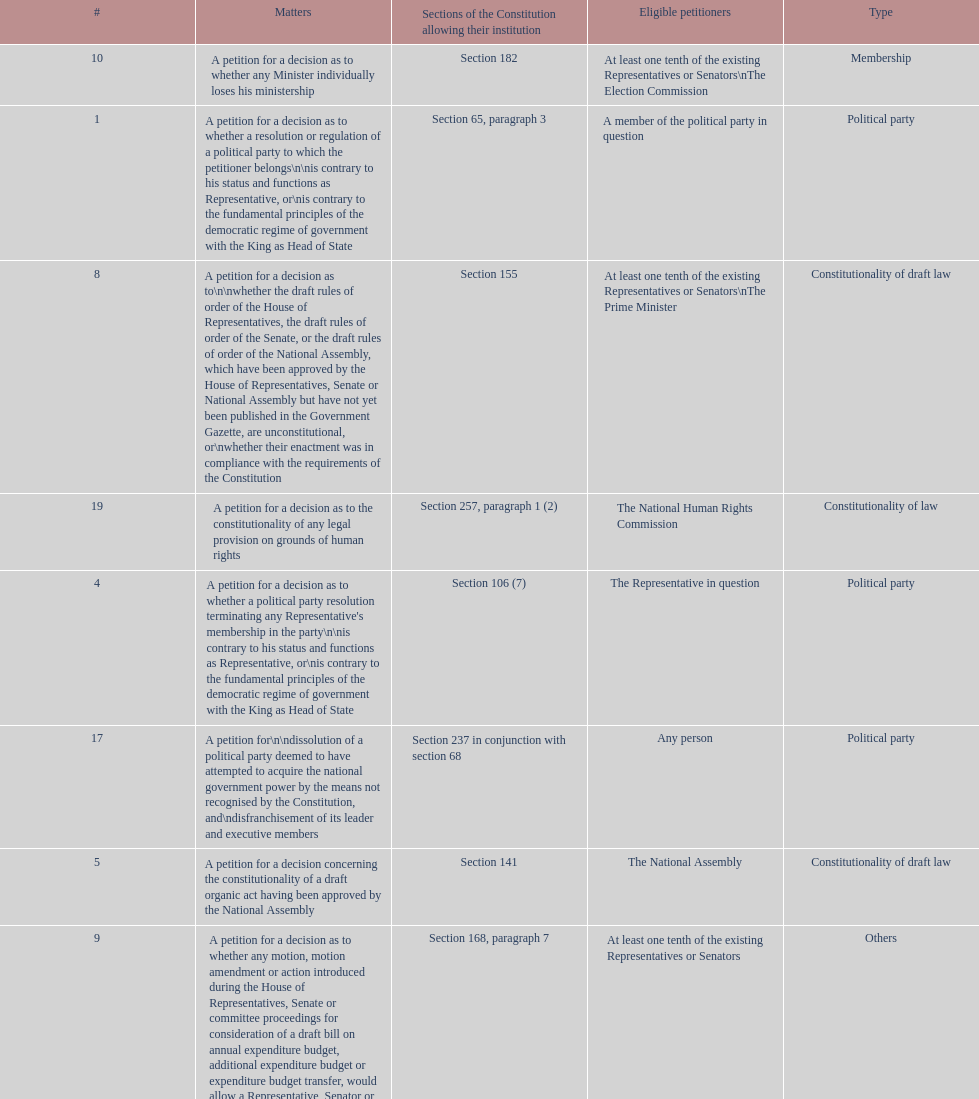Any person can petition matters 2 and 17. true or false? True. Can you parse all the data within this table? {'header': ['#', 'Matters', 'Sections of the Constitution allowing their institution', 'Eligible petitioners', 'Type'], 'rows': [['10', 'A petition for a decision as to whether any Minister individually loses his ministership', 'Section 182', 'At least one tenth of the existing Representatives or Senators\\nThe Election Commission', 'Membership'], ['1', 'A petition for a decision as to whether a resolution or regulation of a political party to which the petitioner belongs\\n\\nis contrary to his status and functions as Representative, or\\nis contrary to the fundamental principles of the democratic regime of government with the King as Head of State', 'Section 65, paragraph 3', 'A member of the political party in question', 'Political party'], ['8', 'A petition for a decision as to\\n\\nwhether the draft rules of order of the House of Representatives, the draft rules of order of the Senate, or the draft rules of order of the National Assembly, which have been approved by the House of Representatives, Senate or National Assembly but have not yet been published in the Government Gazette, are unconstitutional, or\\nwhether their enactment was in compliance with the requirements of the Constitution', 'Section 155', 'At least one tenth of the existing Representatives or Senators\\nThe Prime Minister', 'Constitutionality of draft law'], ['19', 'A petition for a decision as to the constitutionality of any legal provision on grounds of human rights', 'Section 257, paragraph 1 (2)', 'The National Human Rights Commission', 'Constitutionality of law'], ['4', "A petition for a decision as to whether a political party resolution terminating any Representative's membership in the party\\n\\nis contrary to his status and functions as Representative, or\\nis contrary to the fundamental principles of the democratic regime of government with the King as Head of State", 'Section 106 (7)', 'The Representative in question', 'Political party'], ['17', 'A petition for\\n\\ndissolution of a political party deemed to have attempted to acquire the national government power by the means not recognised by the Constitution, and\\ndisfranchisement of its leader and executive members', 'Section 237 in conjunction with section 68', 'Any person', 'Political party'], ['5', 'A petition for a decision concerning the constitutionality of a draft organic act having been approved by the National Assembly', 'Section 141', 'The National Assembly', 'Constitutionality of draft law'], ['9', 'A petition for a decision as to whether any motion, motion amendment or action introduced during the House of Representatives, Senate or committee proceedings for consideration of a draft bill on annual expenditure budget, additional expenditure budget or expenditure budget transfer, would allow a Representative, Senator or committee member to directly or indirectly be involved in the disbursement of such budget', 'Section 168, paragraph 7', 'At least one tenth of the existing Representatives or Senators', 'Others'], ['14', 'A petition for a decision as to the constitutionality of a legal provision', 'Section 212', 'Any person whose constitutionally recognised right or freedom has been violated', 'Constitutionality of law'], ['6', 'A petition for a decision as to whether a draft organic act or act introduced by the Council of Ministers or Representatives bears the principle identical or similar to that which needs to be suppressed', 'Sections 140 and 149', 'The President of the House of Representatives or Senate', 'Constitutionality of draft law'], ['3', 'A petition for a decision as to whether any Representative or Senator loses his membership by operation of the Constitution', 'Section 91', 'At least one tenth of the existing Representatives or Senators', 'Membership'], ['15', 'A petition for a decision as to a conflict of authority between the National Assembly, the Council of Ministers, or two or more constitutional organs other than the courts of justice, administrative courts or military courts', 'Section 214', 'The President of the National Assembly\\nThe Prime Minister\\nThe organs in question', 'Authority'], ['18', 'A petition for a decision as to the constitutionality of any legal provision', 'Section 245 (1)', 'Ombudsmen', 'Constitutionality of law'], ['16', 'A petition for a decision as to whether any Election Commissioner lacks a qualification, is attacked by a disqualification or has committed a prohibited act', 'Section 233', 'At least one tenth of the existing Representatives or Senators', 'Membership'], ['7', 'A petition for a decision as to\\n\\nwhether\\n\\na bill having been approved by the National Assembly by virtue of section 150 but having not yet been submitted to the King by the Prime Minister, or\\na bill having been reapproved by the National Assembly but having not yet been resubmitted to the King by the Prime Minister,\\n\\n\\nis unconstitutional, or\\n\\n\\nwhether its enactment was in compliance with the requirements of the Constitution', 'Section 154', 'At least one tenth of the existing Representatives or Senators\\nThe Prime Minister', 'Constitutionality of draft law'], ['11', 'A petition for a decision as to whether an emergency decree is enacted against section 184, paragraph 1 or 2, of the Constitution', 'Section 185', 'At least one fifth of the existing Representatives or Senators', 'Constitutionality of law'], ['20', 'Other matters permitted by legal provisions', '', '', 'Others'], ['12', 'A petition for a decision as to whether any "written agreement" to be concluded by the Executive Branch requires prior parliamentary approval because\\n\\nit contains a provision which would bring about a change in the Thai territory or the extraterritorial areas over which Thailand is competent to exercise sovereignty or jurisdiction by virtue of a written agreement or international law,\\nits execution requires the enactment of an act,\\nit would extensively affect national economic or social security, or\\nit would considerably bind national trade, investment or budget', 'Section 190', 'At least one tenth of the existing Representatives or Senators', 'Authority'], ['13', 'A petition for a decision as to whether a legal provision to be applied to any case by a court of justice, administrative court or military court is unconstitutional', 'Section 211', 'A party to such case', 'Constitutionality of law'], ['2', 'A petition for a decision as to whether any person or political party exercises the constitutional rights and freedoms\\n\\nto undermine the democratic regime of government with the King as Head of State, or\\nto acquire the national government power by the means not recognised by the Constitution', 'Section 68', 'Any person', 'Constitutional defence']]} 